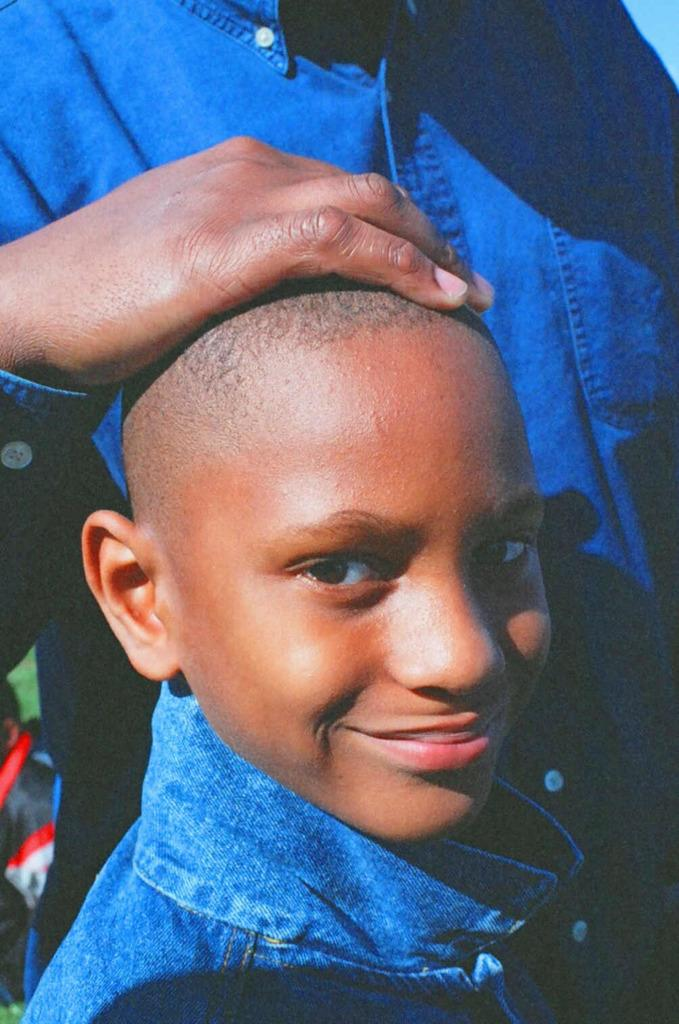What is the main subject of the image? There is a boy in the image. What is the boy doing in the image? The boy is smiling. Are there any other people present in the image? Yes, there is a person standing in the image. What type of scissors is the boy using in the image? There are no scissors present in the image. Can you tell me how the camera is positioned in the image? There is no camera present in the image. 